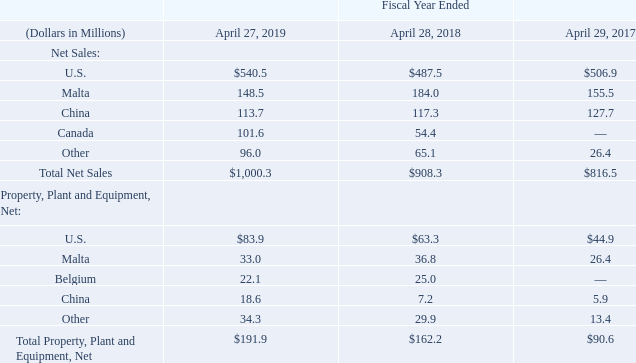11. Segment Information and Geographic Area Information
The following table sets forth certain geographic financial information for fiscal 2019, fiscal 2018 and fiscal 2017. Geographic net sales are determined based on our sales from our various operational locations.
What were the net sales in Malta in 2019?
Answer scale should be: million. 148.5. What were the net sales in U.S. in 2018?
Answer scale should be: million. $487.5. What were the net sales in U.S. in 2019?
Answer scale should be: million. $540.5. What was the change in the net sales from U.S. from 2018 to 2019?
Answer scale should be: million. 540.5 - 487.5
Answer: 53. What was the average net sales from Malta for 2017-2019?
Answer scale should be: million. (148.5 + 184.0 + 155.5) / 3
Answer: 162.67. In which year was Total Net Sales less than 1,000.0 million? Locate and analyze total net sales in row 10
answer: 2018, 2017. 